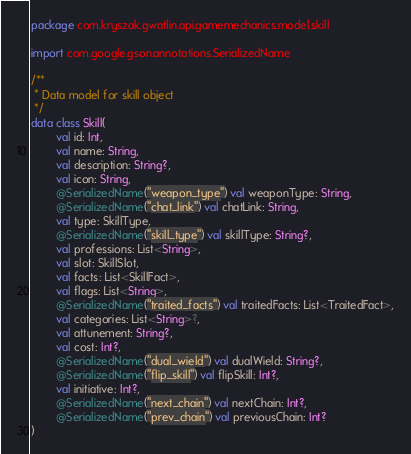Convert code to text. <code><loc_0><loc_0><loc_500><loc_500><_Kotlin_>package com.kryszak.gwatlin.api.gamemechanics.model.skill

import com.google.gson.annotations.SerializedName

/**
 * Data model for skill object
 */
data class Skill(
        val id: Int,
        val name: String,
        val description: String?,
        val icon: String,
        @SerializedName("weapon_type") val weaponType: String,
        @SerializedName("chat_link") val chatLink: String,
        val type: SkillType,
        @SerializedName("skill_type") val skillType: String?,
        val professions: List<String>,
        val slot: SkillSlot,
        val facts: List<SkillFact>,
        val flags: List<String>,
        @SerializedName("traited_facts") val traitedFacts: List<TraitedFact>,
        val categories: List<String>?,
        val attunement: String?,
        val cost: Int?,
        @SerializedName("dual_wield") val dualWield: String?,
        @SerializedName("flip_skill") val flipSkill: Int?,
        val initiative: Int?,
        @SerializedName("next_chain") val nextChain: Int?,
        @SerializedName("prev_chain") val previousChain: Int?
)
</code> 